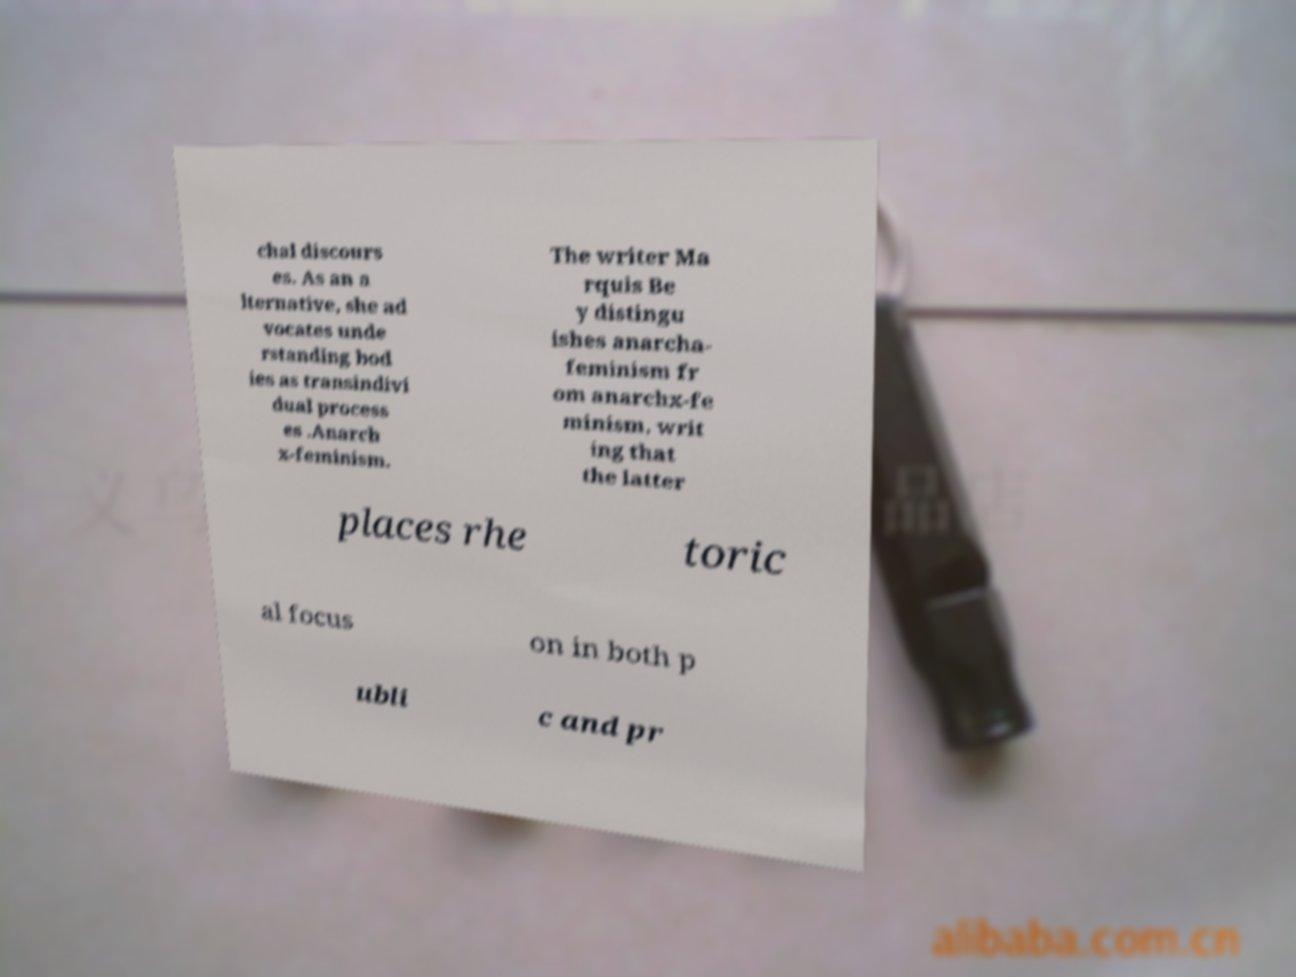Please identify and transcribe the text found in this image. chal discours es. As an a lternative, she ad vocates unde rstanding bod ies as transindivi dual process es .Anarch x-feminism. The writer Ma rquis Be y distingu ishes anarcha- feminism fr om anarchx-fe minism, writ ing that the latter places rhe toric al focus on in both p ubli c and pr 